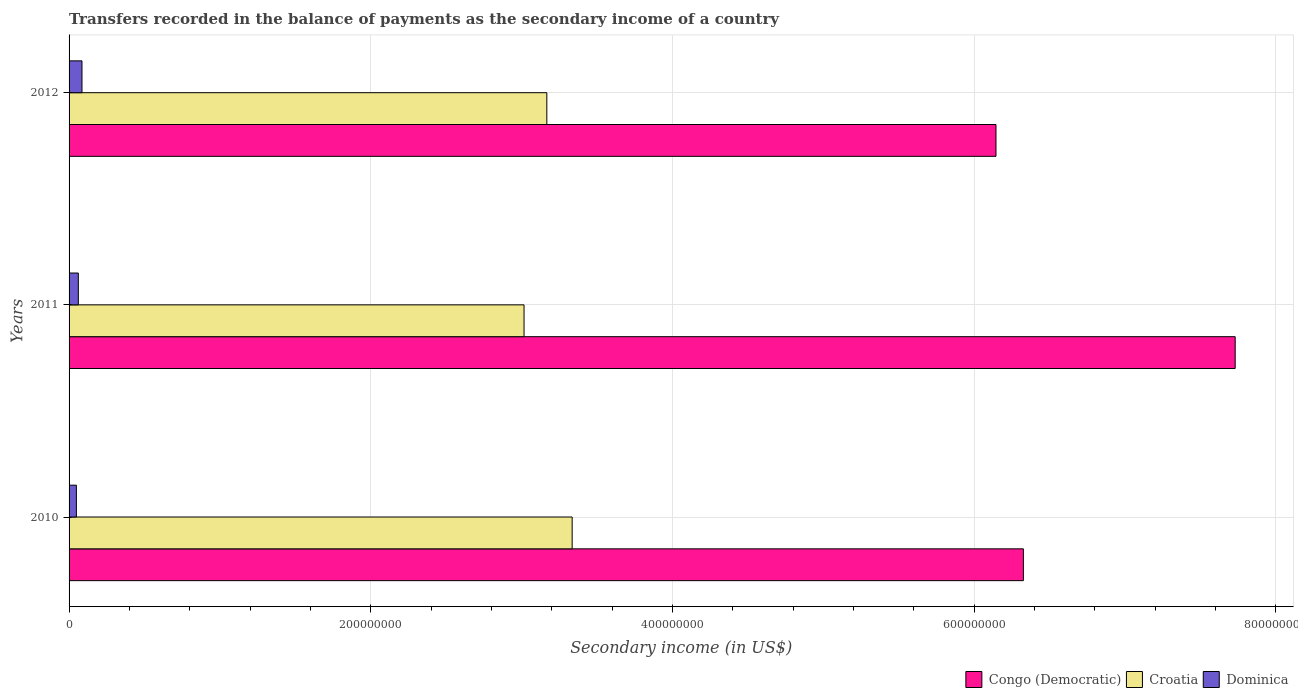Are the number of bars per tick equal to the number of legend labels?
Provide a short and direct response. Yes. How many bars are there on the 3rd tick from the top?
Your answer should be compact. 3. What is the label of the 3rd group of bars from the top?
Keep it short and to the point. 2010. In how many cases, is the number of bars for a given year not equal to the number of legend labels?
Give a very brief answer. 0. What is the secondary income of in Dominica in 2011?
Provide a succinct answer. 6.14e+06. Across all years, what is the maximum secondary income of in Dominica?
Make the answer very short. 8.56e+06. Across all years, what is the minimum secondary income of in Croatia?
Your answer should be very brief. 3.02e+08. In which year was the secondary income of in Croatia maximum?
Your answer should be very brief. 2010. What is the total secondary income of in Congo (Democratic) in the graph?
Your answer should be very brief. 2.02e+09. What is the difference between the secondary income of in Dominica in 2010 and that in 2011?
Provide a short and direct response. -1.28e+06. What is the difference between the secondary income of in Croatia in 2010 and the secondary income of in Dominica in 2012?
Provide a succinct answer. 3.25e+08. What is the average secondary income of in Congo (Democratic) per year?
Your response must be concise. 6.73e+08. In the year 2012, what is the difference between the secondary income of in Croatia and secondary income of in Dominica?
Provide a succinct answer. 3.08e+08. In how many years, is the secondary income of in Croatia greater than 600000000 US$?
Give a very brief answer. 0. What is the ratio of the secondary income of in Congo (Democratic) in 2010 to that in 2012?
Your answer should be very brief. 1.03. Is the difference between the secondary income of in Croatia in 2010 and 2012 greater than the difference between the secondary income of in Dominica in 2010 and 2012?
Provide a succinct answer. Yes. What is the difference between the highest and the second highest secondary income of in Congo (Democratic)?
Keep it short and to the point. 1.40e+08. What is the difference between the highest and the lowest secondary income of in Dominica?
Offer a terse response. 3.70e+06. In how many years, is the secondary income of in Croatia greater than the average secondary income of in Croatia taken over all years?
Make the answer very short. 1. What does the 3rd bar from the top in 2011 represents?
Offer a very short reply. Congo (Democratic). What does the 3rd bar from the bottom in 2010 represents?
Make the answer very short. Dominica. Are the values on the major ticks of X-axis written in scientific E-notation?
Keep it short and to the point. No. Does the graph contain grids?
Offer a terse response. Yes. How are the legend labels stacked?
Give a very brief answer. Horizontal. What is the title of the graph?
Your response must be concise. Transfers recorded in the balance of payments as the secondary income of a country. Does "Belize" appear as one of the legend labels in the graph?
Your answer should be very brief. No. What is the label or title of the X-axis?
Your answer should be compact. Secondary income (in US$). What is the Secondary income (in US$) of Congo (Democratic) in 2010?
Provide a succinct answer. 6.33e+08. What is the Secondary income (in US$) in Croatia in 2010?
Ensure brevity in your answer.  3.33e+08. What is the Secondary income (in US$) in Dominica in 2010?
Keep it short and to the point. 4.85e+06. What is the Secondary income (in US$) of Congo (Democratic) in 2011?
Make the answer very short. 7.73e+08. What is the Secondary income (in US$) of Croatia in 2011?
Your answer should be very brief. 3.02e+08. What is the Secondary income (in US$) in Dominica in 2011?
Offer a very short reply. 6.14e+06. What is the Secondary income (in US$) in Congo (Democratic) in 2012?
Give a very brief answer. 6.14e+08. What is the Secondary income (in US$) of Croatia in 2012?
Provide a short and direct response. 3.17e+08. What is the Secondary income (in US$) of Dominica in 2012?
Offer a very short reply. 8.56e+06. Across all years, what is the maximum Secondary income (in US$) in Congo (Democratic)?
Make the answer very short. 7.73e+08. Across all years, what is the maximum Secondary income (in US$) in Croatia?
Give a very brief answer. 3.33e+08. Across all years, what is the maximum Secondary income (in US$) in Dominica?
Offer a terse response. 8.56e+06. Across all years, what is the minimum Secondary income (in US$) of Congo (Democratic)?
Your answer should be compact. 6.14e+08. Across all years, what is the minimum Secondary income (in US$) in Croatia?
Provide a short and direct response. 3.02e+08. Across all years, what is the minimum Secondary income (in US$) in Dominica?
Provide a succinct answer. 4.85e+06. What is the total Secondary income (in US$) of Congo (Democratic) in the graph?
Your response must be concise. 2.02e+09. What is the total Secondary income (in US$) in Croatia in the graph?
Provide a succinct answer. 9.52e+08. What is the total Secondary income (in US$) in Dominica in the graph?
Give a very brief answer. 1.95e+07. What is the difference between the Secondary income (in US$) in Congo (Democratic) in 2010 and that in 2011?
Provide a succinct answer. -1.40e+08. What is the difference between the Secondary income (in US$) in Croatia in 2010 and that in 2011?
Your response must be concise. 3.19e+07. What is the difference between the Secondary income (in US$) of Dominica in 2010 and that in 2011?
Ensure brevity in your answer.  -1.28e+06. What is the difference between the Secondary income (in US$) in Congo (Democratic) in 2010 and that in 2012?
Your answer should be compact. 1.82e+07. What is the difference between the Secondary income (in US$) of Croatia in 2010 and that in 2012?
Make the answer very short. 1.68e+07. What is the difference between the Secondary income (in US$) of Dominica in 2010 and that in 2012?
Offer a terse response. -3.70e+06. What is the difference between the Secondary income (in US$) in Congo (Democratic) in 2011 and that in 2012?
Offer a terse response. 1.59e+08. What is the difference between the Secondary income (in US$) in Croatia in 2011 and that in 2012?
Offer a very short reply. -1.51e+07. What is the difference between the Secondary income (in US$) of Dominica in 2011 and that in 2012?
Your response must be concise. -2.42e+06. What is the difference between the Secondary income (in US$) in Congo (Democratic) in 2010 and the Secondary income (in US$) in Croatia in 2011?
Ensure brevity in your answer.  3.31e+08. What is the difference between the Secondary income (in US$) of Congo (Democratic) in 2010 and the Secondary income (in US$) of Dominica in 2011?
Provide a succinct answer. 6.26e+08. What is the difference between the Secondary income (in US$) in Croatia in 2010 and the Secondary income (in US$) in Dominica in 2011?
Provide a succinct answer. 3.27e+08. What is the difference between the Secondary income (in US$) in Congo (Democratic) in 2010 and the Secondary income (in US$) in Croatia in 2012?
Your answer should be very brief. 3.16e+08. What is the difference between the Secondary income (in US$) in Congo (Democratic) in 2010 and the Secondary income (in US$) in Dominica in 2012?
Offer a very short reply. 6.24e+08. What is the difference between the Secondary income (in US$) in Croatia in 2010 and the Secondary income (in US$) in Dominica in 2012?
Your answer should be very brief. 3.25e+08. What is the difference between the Secondary income (in US$) of Congo (Democratic) in 2011 and the Secondary income (in US$) of Croatia in 2012?
Keep it short and to the point. 4.56e+08. What is the difference between the Secondary income (in US$) of Congo (Democratic) in 2011 and the Secondary income (in US$) of Dominica in 2012?
Make the answer very short. 7.64e+08. What is the difference between the Secondary income (in US$) of Croatia in 2011 and the Secondary income (in US$) of Dominica in 2012?
Ensure brevity in your answer.  2.93e+08. What is the average Secondary income (in US$) of Congo (Democratic) per year?
Keep it short and to the point. 6.73e+08. What is the average Secondary income (in US$) of Croatia per year?
Provide a short and direct response. 3.17e+08. What is the average Secondary income (in US$) of Dominica per year?
Your answer should be compact. 6.52e+06. In the year 2010, what is the difference between the Secondary income (in US$) of Congo (Democratic) and Secondary income (in US$) of Croatia?
Your response must be concise. 2.99e+08. In the year 2010, what is the difference between the Secondary income (in US$) of Congo (Democratic) and Secondary income (in US$) of Dominica?
Give a very brief answer. 6.28e+08. In the year 2010, what is the difference between the Secondary income (in US$) in Croatia and Secondary income (in US$) in Dominica?
Make the answer very short. 3.29e+08. In the year 2011, what is the difference between the Secondary income (in US$) in Congo (Democratic) and Secondary income (in US$) in Croatia?
Offer a very short reply. 4.71e+08. In the year 2011, what is the difference between the Secondary income (in US$) of Congo (Democratic) and Secondary income (in US$) of Dominica?
Your answer should be compact. 7.67e+08. In the year 2011, what is the difference between the Secondary income (in US$) in Croatia and Secondary income (in US$) in Dominica?
Give a very brief answer. 2.95e+08. In the year 2012, what is the difference between the Secondary income (in US$) in Congo (Democratic) and Secondary income (in US$) in Croatia?
Your answer should be very brief. 2.98e+08. In the year 2012, what is the difference between the Secondary income (in US$) in Congo (Democratic) and Secondary income (in US$) in Dominica?
Provide a succinct answer. 6.06e+08. In the year 2012, what is the difference between the Secondary income (in US$) in Croatia and Secondary income (in US$) in Dominica?
Your answer should be very brief. 3.08e+08. What is the ratio of the Secondary income (in US$) in Congo (Democratic) in 2010 to that in 2011?
Your response must be concise. 0.82. What is the ratio of the Secondary income (in US$) of Croatia in 2010 to that in 2011?
Provide a short and direct response. 1.11. What is the ratio of the Secondary income (in US$) of Dominica in 2010 to that in 2011?
Keep it short and to the point. 0.79. What is the ratio of the Secondary income (in US$) in Congo (Democratic) in 2010 to that in 2012?
Ensure brevity in your answer.  1.03. What is the ratio of the Secondary income (in US$) in Croatia in 2010 to that in 2012?
Give a very brief answer. 1.05. What is the ratio of the Secondary income (in US$) of Dominica in 2010 to that in 2012?
Your answer should be compact. 0.57. What is the ratio of the Secondary income (in US$) in Congo (Democratic) in 2011 to that in 2012?
Give a very brief answer. 1.26. What is the ratio of the Secondary income (in US$) of Croatia in 2011 to that in 2012?
Provide a succinct answer. 0.95. What is the ratio of the Secondary income (in US$) in Dominica in 2011 to that in 2012?
Your answer should be very brief. 0.72. What is the difference between the highest and the second highest Secondary income (in US$) in Congo (Democratic)?
Your response must be concise. 1.40e+08. What is the difference between the highest and the second highest Secondary income (in US$) in Croatia?
Make the answer very short. 1.68e+07. What is the difference between the highest and the second highest Secondary income (in US$) in Dominica?
Offer a terse response. 2.42e+06. What is the difference between the highest and the lowest Secondary income (in US$) in Congo (Democratic)?
Your answer should be compact. 1.59e+08. What is the difference between the highest and the lowest Secondary income (in US$) of Croatia?
Ensure brevity in your answer.  3.19e+07. What is the difference between the highest and the lowest Secondary income (in US$) of Dominica?
Give a very brief answer. 3.70e+06. 